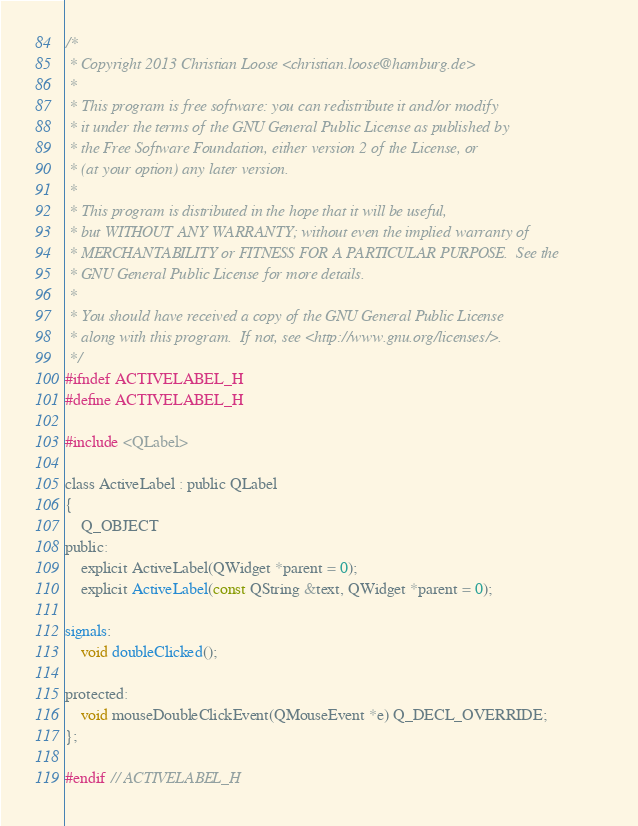<code> <loc_0><loc_0><loc_500><loc_500><_C_>/*
 * Copyright 2013 Christian Loose <christian.loose@hamburg.de>
 *
 * This program is free software: you can redistribute it and/or modify
 * it under the terms of the GNU General Public License as published by
 * the Free Software Foundation, either version 2 of the License, or
 * (at your option) any later version.
 *
 * This program is distributed in the hope that it will be useful,
 * but WITHOUT ANY WARRANTY; without even the implied warranty of
 * MERCHANTABILITY or FITNESS FOR A PARTICULAR PURPOSE.  See the
 * GNU General Public License for more details.
 *
 * You should have received a copy of the GNU General Public License
 * along with this program.  If not, see <http://www.gnu.org/licenses/>.
 */
#ifndef ACTIVELABEL_H
#define ACTIVELABEL_H

#include <QLabel>

class ActiveLabel : public QLabel
{
    Q_OBJECT
public:
    explicit ActiveLabel(QWidget *parent = 0);
    explicit ActiveLabel(const QString &text, QWidget *parent = 0);

signals:
    void doubleClicked();
    
protected:
    void mouseDoubleClickEvent(QMouseEvent *e) Q_DECL_OVERRIDE;
};

#endif // ACTIVELABEL_H
</code> 